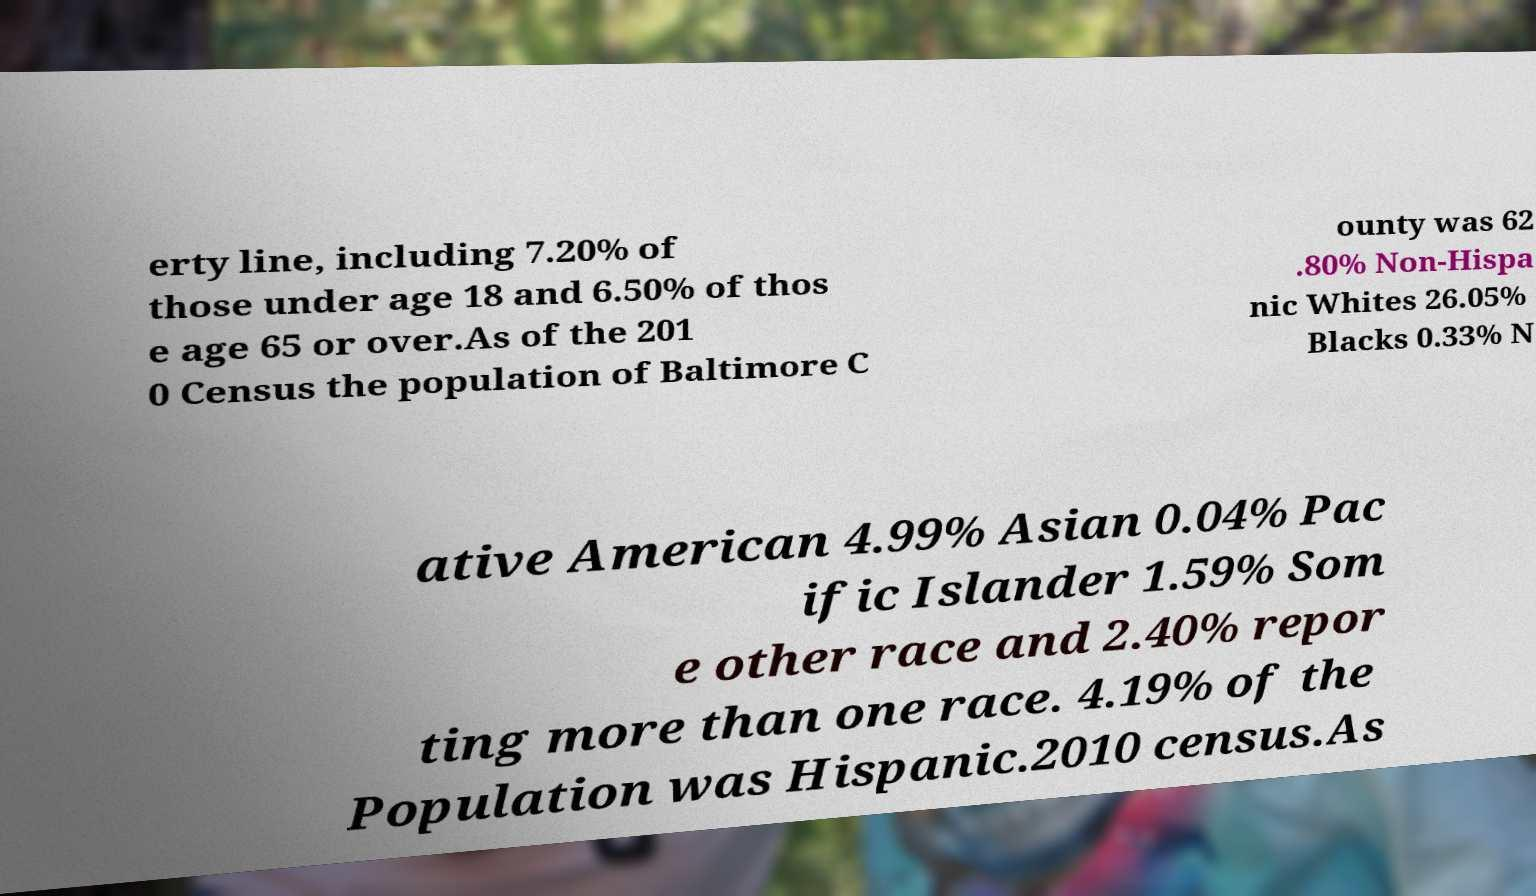There's text embedded in this image that I need extracted. Can you transcribe it verbatim? erty line, including 7.20% of those under age 18 and 6.50% of thos e age 65 or over.As of the 201 0 Census the population of Baltimore C ounty was 62 .80% Non-Hispa nic Whites 26.05% Blacks 0.33% N ative American 4.99% Asian 0.04% Pac ific Islander 1.59% Som e other race and 2.40% repor ting more than one race. 4.19% of the Population was Hispanic.2010 census.As 